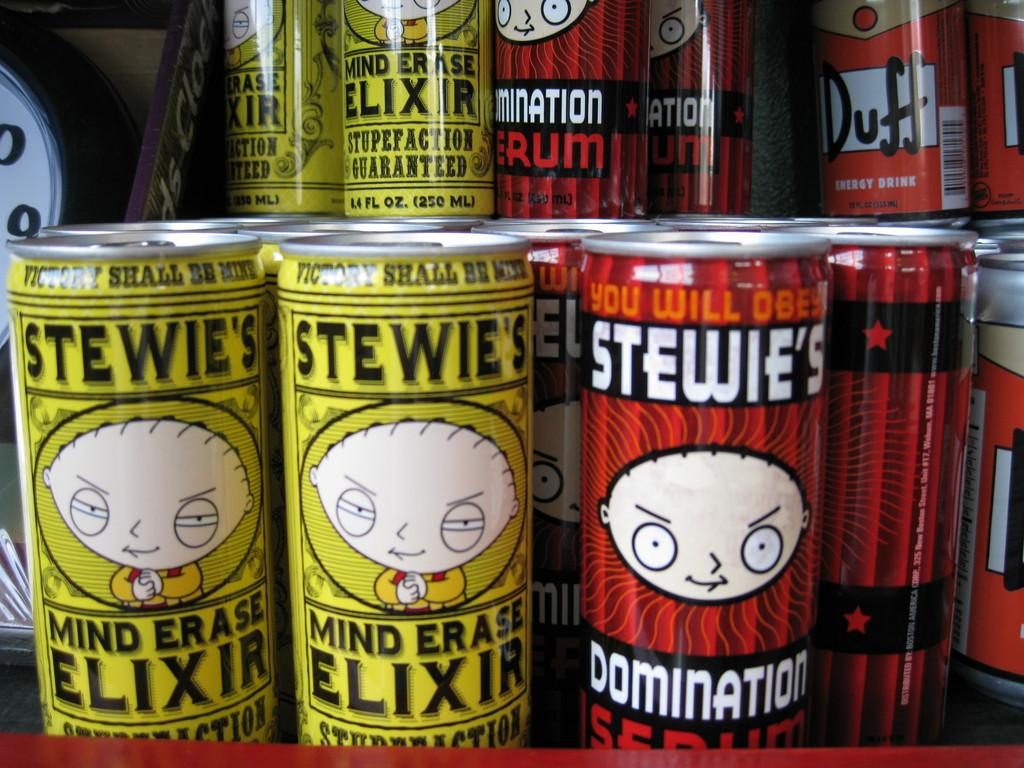Provide a one-sentence caption for the provided image. Quite a few cans of energy drinks, mainly Stewie's Mind Erase Elixir and Elimination Serum, are on display. 